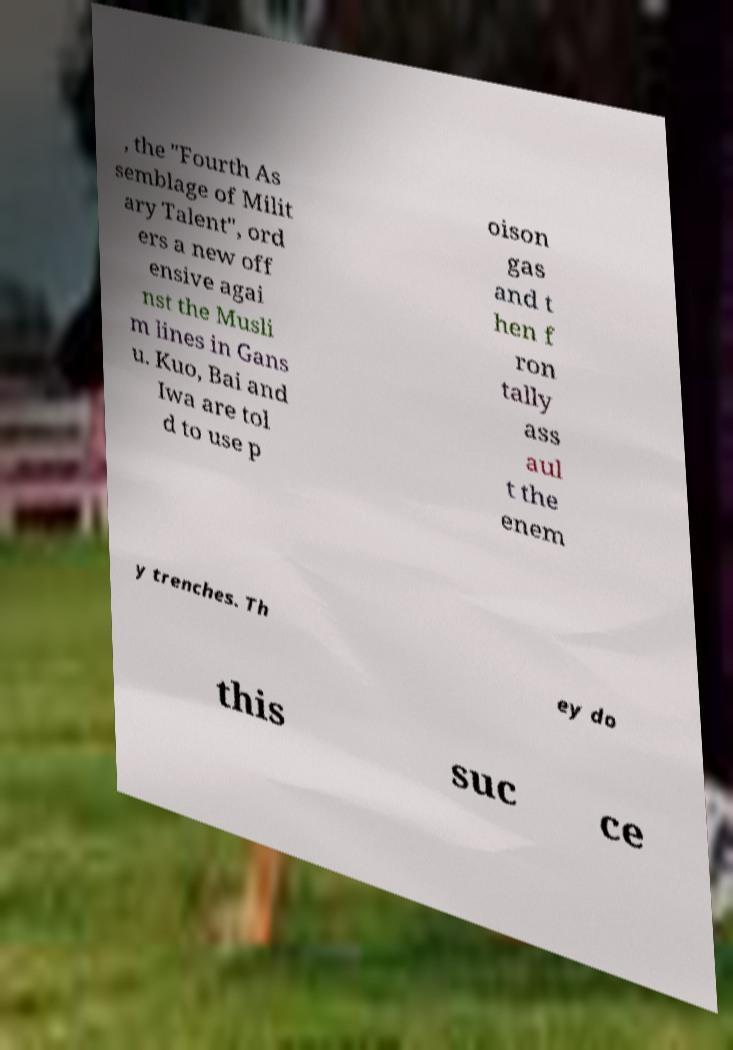There's text embedded in this image that I need extracted. Can you transcribe it verbatim? , the "Fourth As semblage of Milit ary Talent", ord ers a new off ensive agai nst the Musli m lines in Gans u. Kuo, Bai and Iwa are tol d to use p oison gas and t hen f ron tally ass aul t the enem y trenches. Th ey do this suc ce 